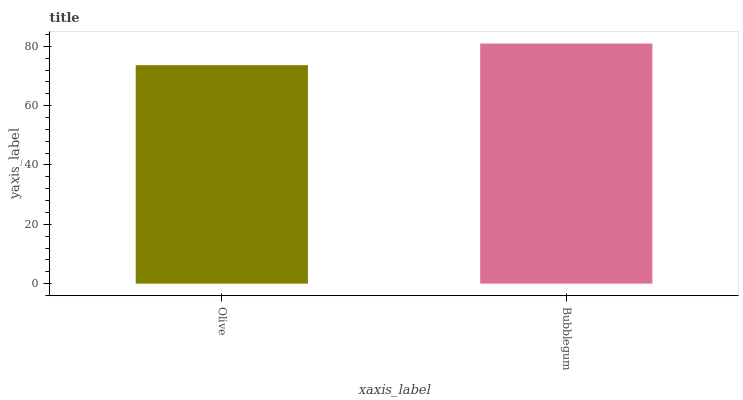Is Olive the minimum?
Answer yes or no. Yes. Is Bubblegum the maximum?
Answer yes or no. Yes. Is Bubblegum the minimum?
Answer yes or no. No. Is Bubblegum greater than Olive?
Answer yes or no. Yes. Is Olive less than Bubblegum?
Answer yes or no. Yes. Is Olive greater than Bubblegum?
Answer yes or no. No. Is Bubblegum less than Olive?
Answer yes or no. No. Is Bubblegum the high median?
Answer yes or no. Yes. Is Olive the low median?
Answer yes or no. Yes. Is Olive the high median?
Answer yes or no. No. Is Bubblegum the low median?
Answer yes or no. No. 